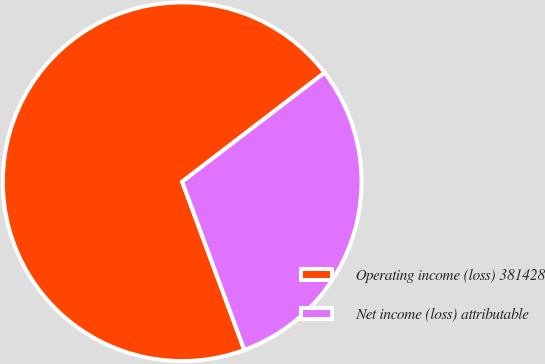Convert chart. <chart><loc_0><loc_0><loc_500><loc_500><pie_chart><fcel>Operating income (loss) 381428<fcel>Net income (loss) attributable<nl><fcel>70.23%<fcel>29.77%<nl></chart> 